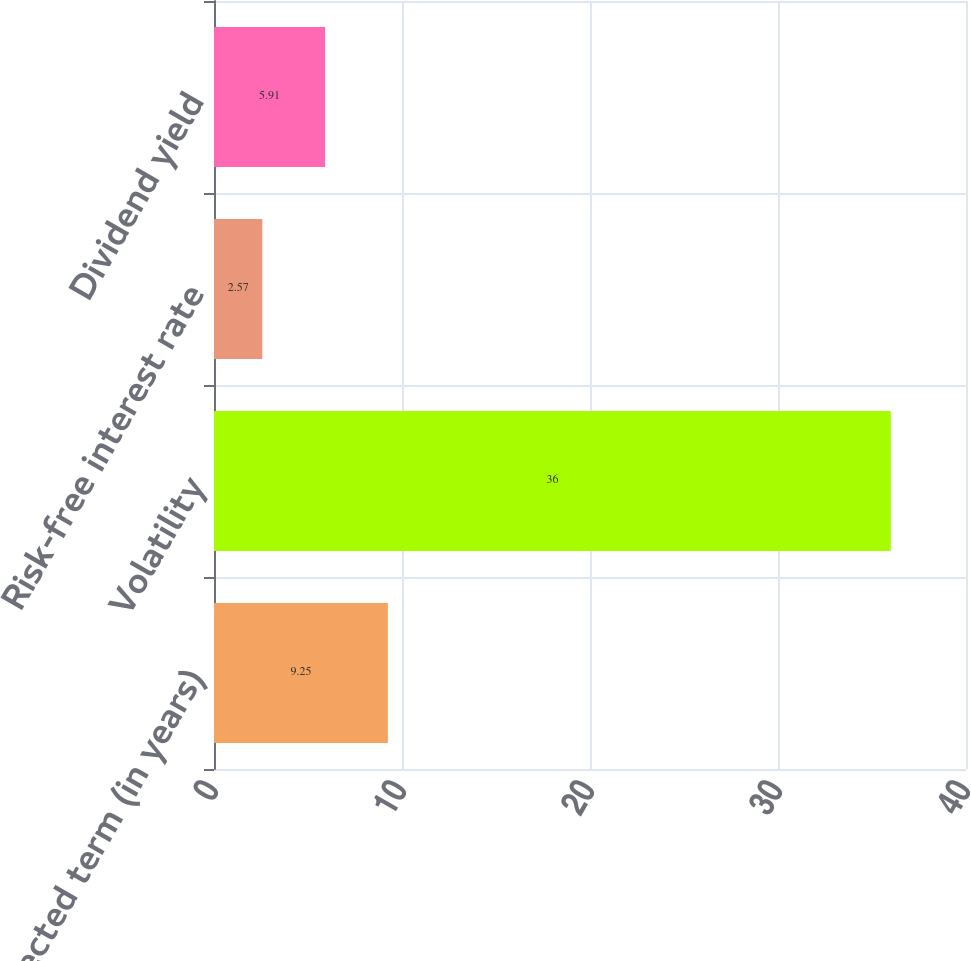Convert chart to OTSL. <chart><loc_0><loc_0><loc_500><loc_500><bar_chart><fcel>Expected term (in years)<fcel>Volatility<fcel>Risk-free interest rate<fcel>Dividend yield<nl><fcel>9.25<fcel>36<fcel>2.57<fcel>5.91<nl></chart> 